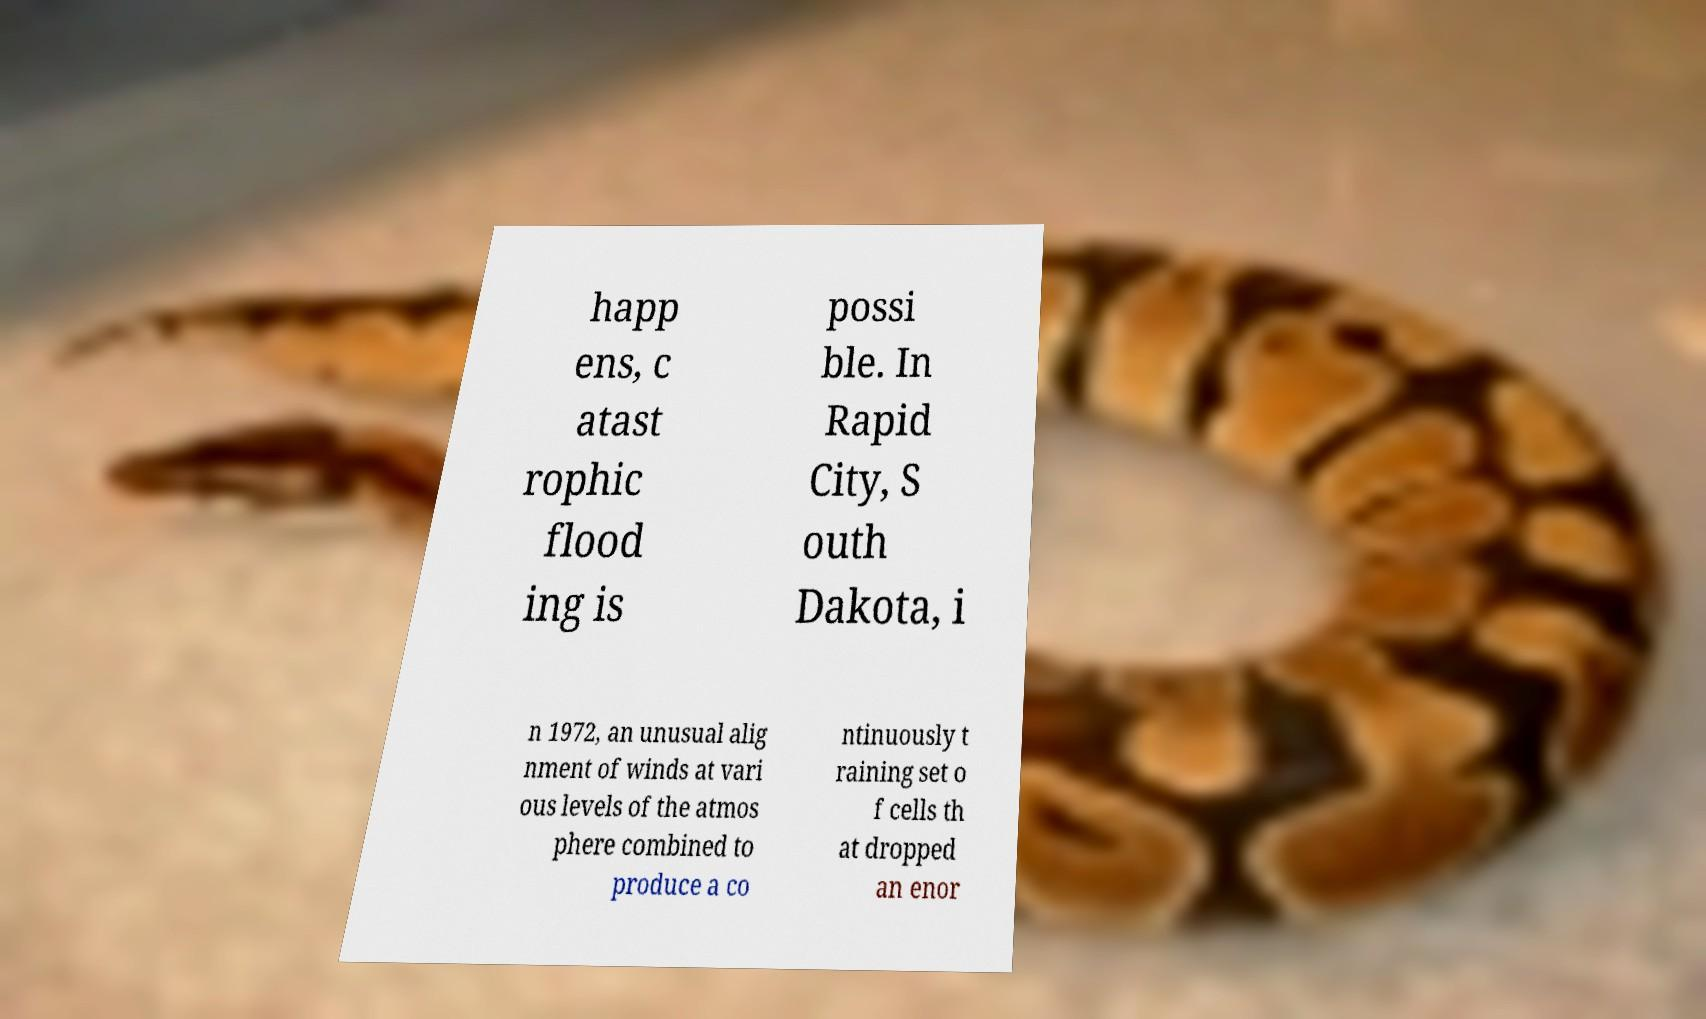What messages or text are displayed in this image? I need them in a readable, typed format. happ ens, c atast rophic flood ing is possi ble. In Rapid City, S outh Dakota, i n 1972, an unusual alig nment of winds at vari ous levels of the atmos phere combined to produce a co ntinuously t raining set o f cells th at dropped an enor 